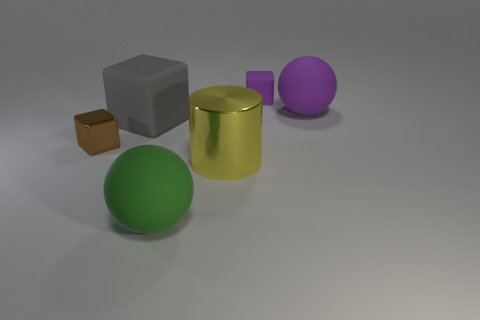Do the rubber block on the right side of the metal cylinder and the purple thing in front of the small purple matte thing have the same size?
Your answer should be compact. No. Do the yellow metallic cylinder and the matte ball that is in front of the tiny metal object have the same size?
Your answer should be very brief. Yes. What is the size of the yellow cylinder?
Your answer should be very brief. Large. What color is the ball that is made of the same material as the big purple object?
Make the answer very short. Green. How many balls have the same material as the tiny purple thing?
Offer a very short reply. 2. What number of objects are either small brown things or large things in front of the big yellow metallic thing?
Your answer should be very brief. 2. Do the purple object left of the purple sphere and the large purple object have the same material?
Your answer should be compact. Yes. What color is the rubber cube that is the same size as the green rubber ball?
Offer a very short reply. Gray. Is there a cyan object that has the same shape as the large yellow shiny thing?
Provide a short and direct response. No. There is a cube that is behind the ball right of the rubber ball that is in front of the gray rubber block; what is its color?
Provide a succinct answer. Purple. 